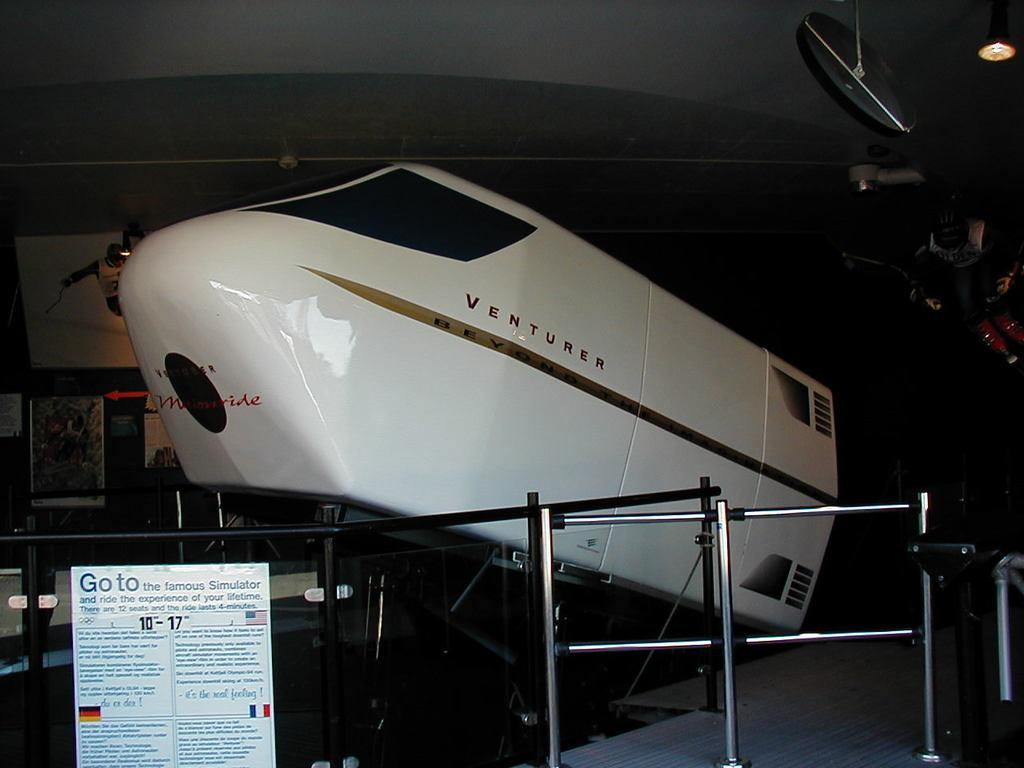<image>
Provide a brief description of the given image. the word venturer is on the side of the train 